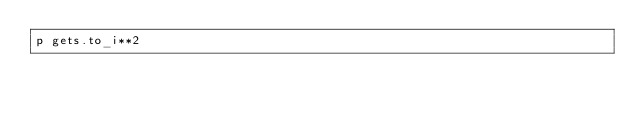<code> <loc_0><loc_0><loc_500><loc_500><_Ruby_>p gets.to_i**2</code> 